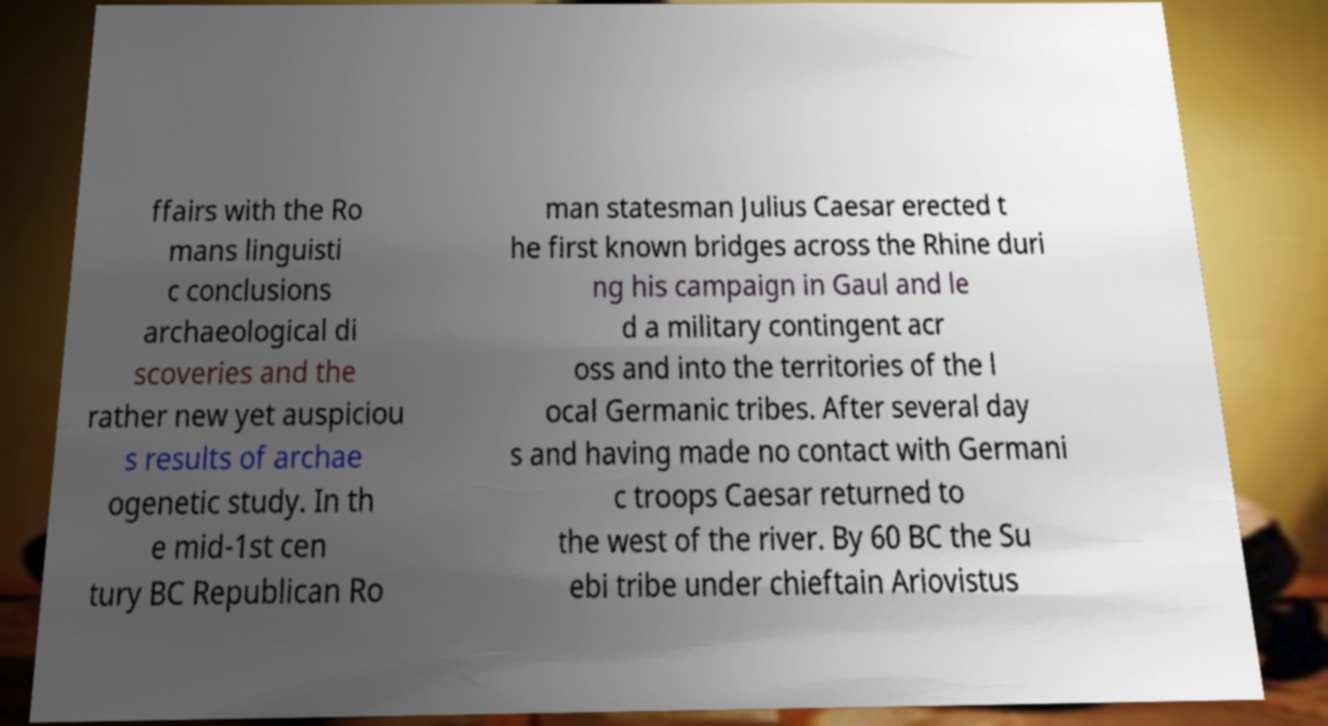Can you accurately transcribe the text from the provided image for me? ffairs with the Ro mans linguisti c conclusions archaeological di scoveries and the rather new yet auspiciou s results of archae ogenetic study. In th e mid-1st cen tury BC Republican Ro man statesman Julius Caesar erected t he first known bridges across the Rhine duri ng his campaign in Gaul and le d a military contingent acr oss and into the territories of the l ocal Germanic tribes. After several day s and having made no contact with Germani c troops Caesar returned to the west of the river. By 60 BC the Su ebi tribe under chieftain Ariovistus 